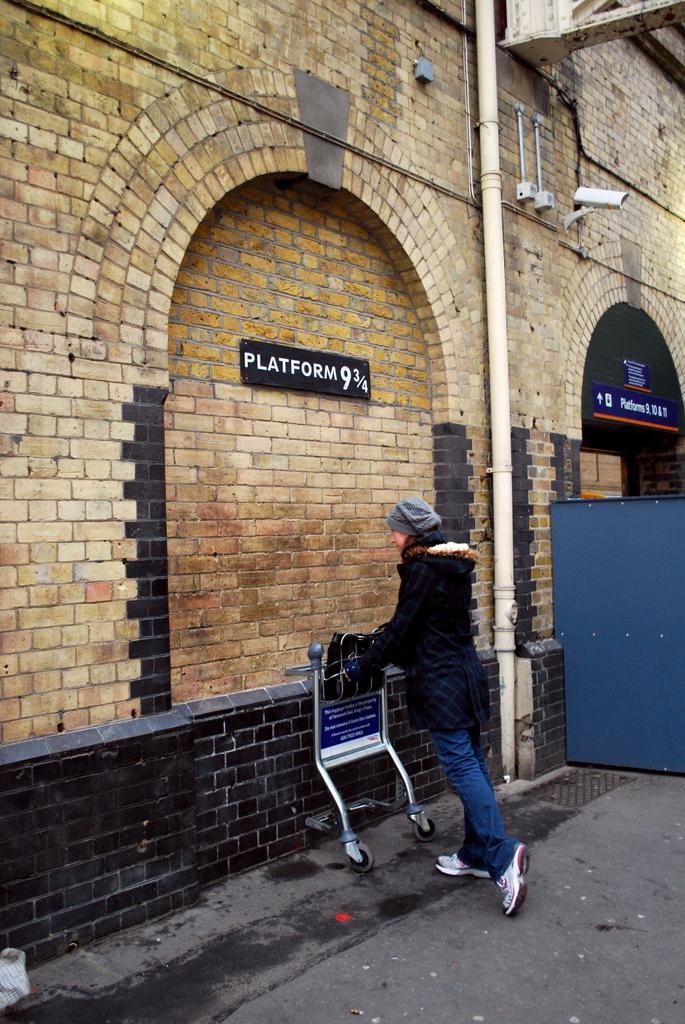In one or two sentences, can you explain what this image depicts? In this image we can see a person holding a wheelchair in the hands. Here we can see the Closed Circuit Television on the wall and it is on the right side. Here we can see the pipeline on the wall. Here we can see the brick wall. Here we can see the arch design on the wall. Here we can see the metal sheet on the right side. 